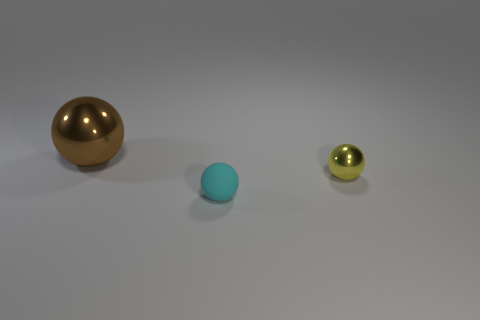What is the cyan sphere made of?
Provide a short and direct response. Rubber. Are any brown metallic spheres visible?
Your response must be concise. Yes. The metal thing that is right of the small cyan matte thing is what color?
Give a very brief answer. Yellow. What number of cyan objects are behind the shiny object in front of the metal thing that is to the left of the matte object?
Your answer should be very brief. 0. What is the material of the object that is both left of the yellow shiny object and behind the matte object?
Offer a very short reply. Metal. Are the large ball and the tiny sphere on the left side of the small yellow ball made of the same material?
Provide a short and direct response. No. Are there more tiny matte objects that are on the left side of the big metallic object than large metal balls right of the yellow ball?
Your answer should be very brief. No. What is the shape of the matte object?
Your answer should be compact. Sphere. Do the small ball that is in front of the tiny yellow shiny thing and the object that is behind the yellow thing have the same material?
Keep it short and to the point. No. What shape is the metal object that is to the left of the tiny cyan object?
Give a very brief answer. Sphere. 